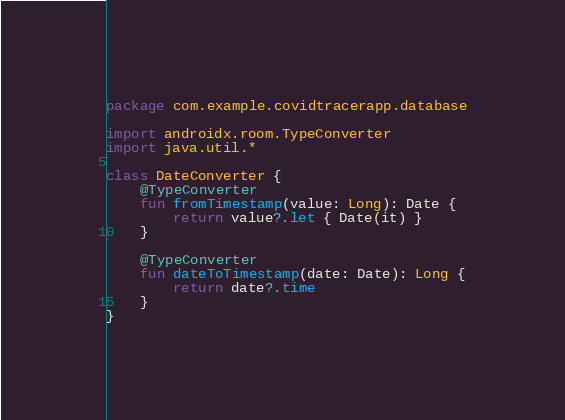Convert code to text. <code><loc_0><loc_0><loc_500><loc_500><_Kotlin_>package com.example.covidtracerapp.database

import androidx.room.TypeConverter
import java.util.*

class DateConverter {
    @TypeConverter
    fun fromTimestamp(value: Long): Date {
        return value?.let { Date(it) }
    }

    @TypeConverter
    fun dateToTimestamp(date: Date): Long {
        return date?.time
    }
}</code> 